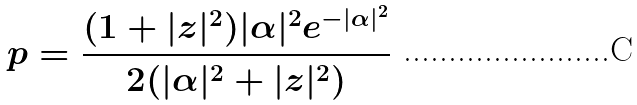Convert formula to latex. <formula><loc_0><loc_0><loc_500><loc_500>p = \frac { ( 1 + | z | ^ { 2 } ) | \alpha | ^ { 2 } e ^ { - | \alpha | ^ { 2 } } } { 2 ( | \alpha | ^ { 2 } + | z | ^ { 2 } ) }</formula> 